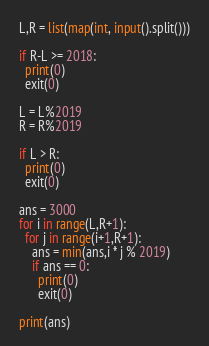<code> <loc_0><loc_0><loc_500><loc_500><_Python_>L,R = list(map(int, input().split()))

if R-L >= 2018:
  print(0)
  exit(0)
  
L = L%2019
R = R%2019

if L > R:
  print(0)
  exit(0)
  
ans = 3000
for i in range(L,R+1):
  for j in range(i+1,R+1):
    ans = min(ans,i * j % 2019)
    if ans == 0:
      print(0)
      exit(0)
    
print(ans)</code> 